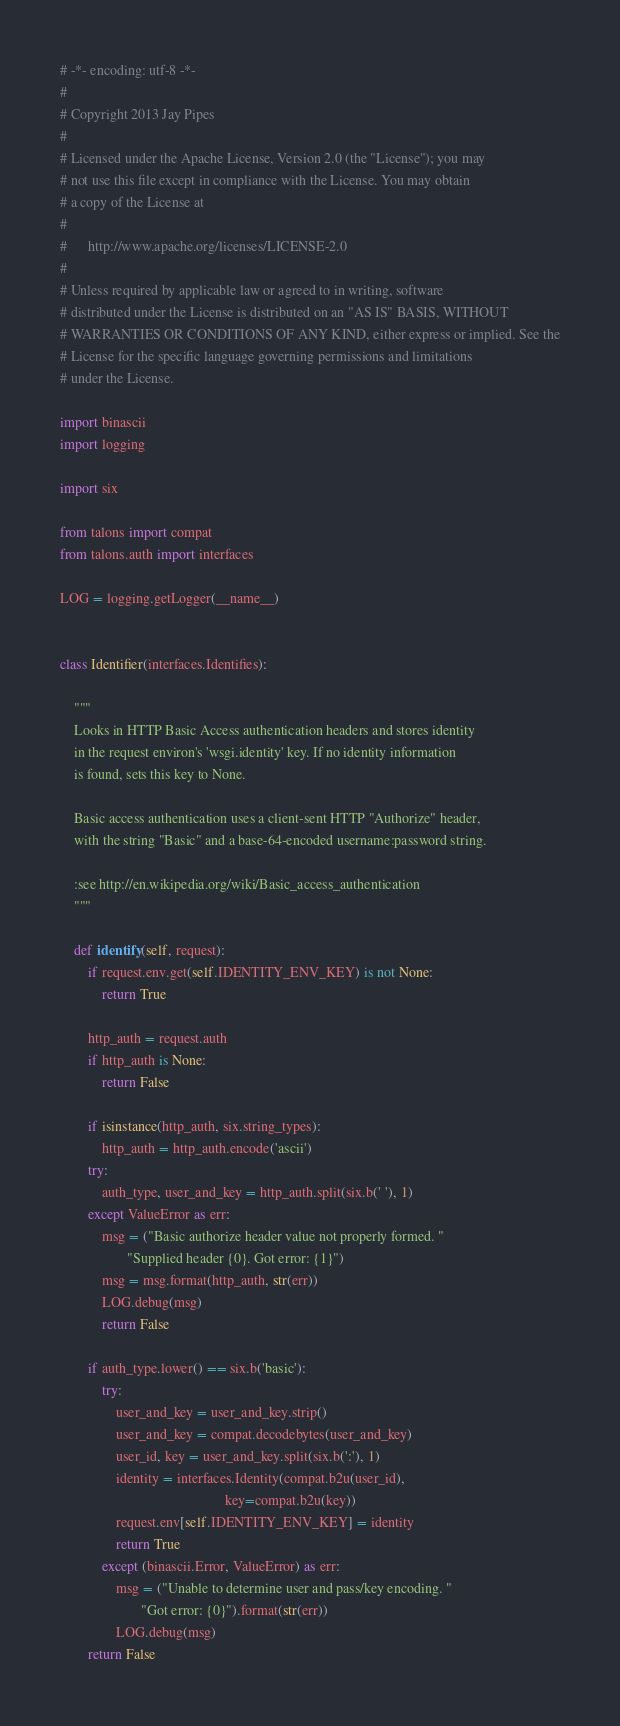Convert code to text. <code><loc_0><loc_0><loc_500><loc_500><_Python_># -*- encoding: utf-8 -*-
#
# Copyright 2013 Jay Pipes
#
# Licensed under the Apache License, Version 2.0 (the "License"); you may
# not use this file except in compliance with the License. You may obtain
# a copy of the License at
#
#      http://www.apache.org/licenses/LICENSE-2.0
#
# Unless required by applicable law or agreed to in writing, software
# distributed under the License is distributed on an "AS IS" BASIS, WITHOUT
# WARRANTIES OR CONDITIONS OF ANY KIND, either express or implied. See the
# License for the specific language governing permissions and limitations
# under the License.

import binascii
import logging

import six

from talons import compat
from talons.auth import interfaces

LOG = logging.getLogger(__name__)


class Identifier(interfaces.Identifies):

    """
    Looks in HTTP Basic Access authentication headers and stores identity
    in the request environ's 'wsgi.identity' key. If no identity information
    is found, sets this key to None.

    Basic access authentication uses a client-sent HTTP "Authorize" header,
    with the string "Basic" and a base-64-encoded username:password string.

    :see http://en.wikipedia.org/wiki/Basic_access_authentication
    """

    def identify(self, request):
        if request.env.get(self.IDENTITY_ENV_KEY) is not None:
            return True

        http_auth = request.auth
        if http_auth is None:
            return False

        if isinstance(http_auth, six.string_types):
            http_auth = http_auth.encode('ascii')
        try:
            auth_type, user_and_key = http_auth.split(six.b(' '), 1)
        except ValueError as err:
            msg = ("Basic authorize header value not properly formed. "
                   "Supplied header {0}. Got error: {1}")
            msg = msg.format(http_auth, str(err))
            LOG.debug(msg)
            return False

        if auth_type.lower() == six.b('basic'):
            try:
                user_and_key = user_and_key.strip()
                user_and_key = compat.decodebytes(user_and_key)
                user_id, key = user_and_key.split(six.b(':'), 1)
                identity = interfaces.Identity(compat.b2u(user_id),
                                               key=compat.b2u(key))
                request.env[self.IDENTITY_ENV_KEY] = identity
                return True
            except (binascii.Error, ValueError) as err:
                msg = ("Unable to determine user and pass/key encoding. "
                       "Got error: {0}").format(str(err))
                LOG.debug(msg)
        return False
</code> 